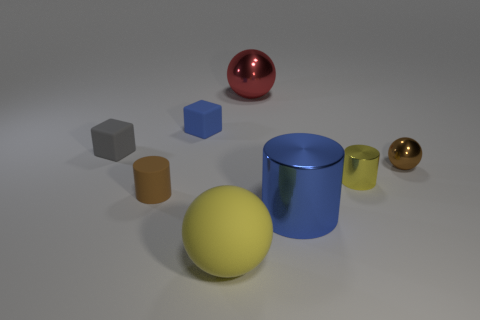Subtract all yellow balls. How many balls are left? 2 Subtract all yellow cylinders. How many cylinders are left? 2 Add 2 big green cylinders. How many objects exist? 10 Subtract 1 cubes. How many cubes are left? 1 Add 5 brown metal spheres. How many brown metal spheres are left? 6 Add 1 brown spheres. How many brown spheres exist? 2 Subtract 0 purple spheres. How many objects are left? 8 Subtract all blocks. How many objects are left? 6 Subtract all gray spheres. Subtract all cyan blocks. How many spheres are left? 3 Subtract all green blocks. How many yellow balls are left? 1 